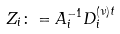<formula> <loc_0><loc_0><loc_500><loc_500>Z _ { i } \colon = A _ { i } ^ { - 1 } D ^ { ( \nu ) t } _ { i }</formula> 